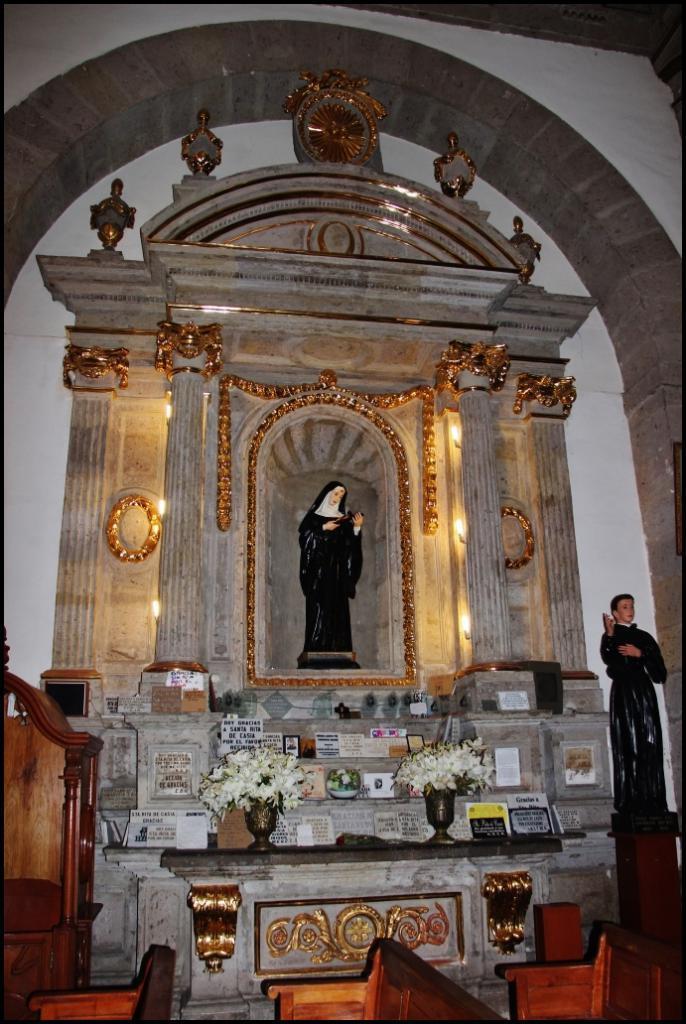Could you give a brief overview of what you see in this image? In this image I can see few benches which are brown in color and a white colored wall in which I can see a statue. I can see another statue of a person wearing black colored dress, few flowers which are cream in color and few other objects. I can see the arch which is gold and grey in color. 